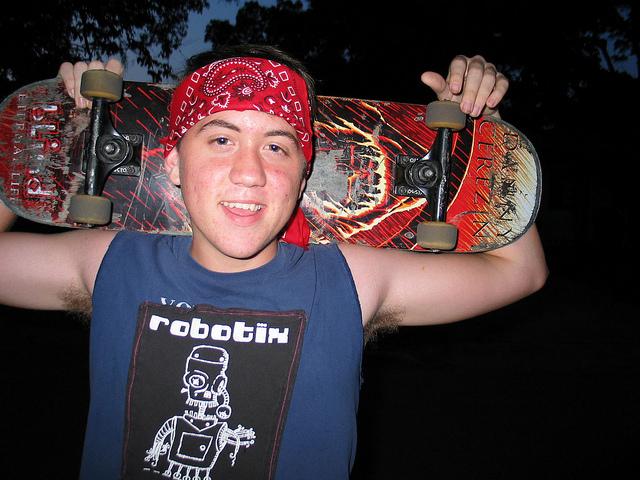What does the person have on his forehead?
Keep it brief. Bandana. What is the man holding?
Quick response, please. Skateboard. Is the skateboard holding the man hostage?
Quick response, please. No. 